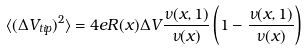<formula> <loc_0><loc_0><loc_500><loc_500>\langle ( \Delta V _ { t i p } ) ^ { 2 } \rangle = 4 e R ( x ) \Delta V \frac { \nu ( x , 1 ) } { \nu ( x ) } \left ( 1 - \frac { \nu ( x , 1 ) } { \nu ( x ) } \right )</formula> 